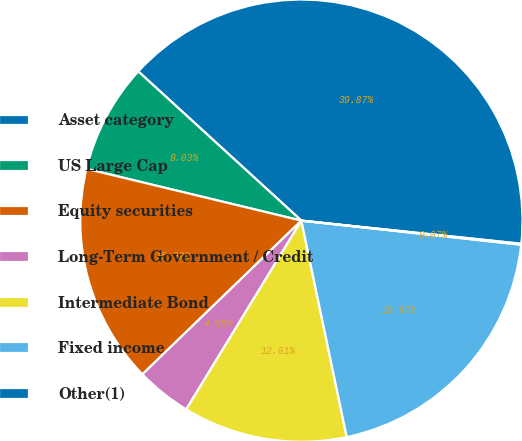Convert chart. <chart><loc_0><loc_0><loc_500><loc_500><pie_chart><fcel>Asset category<fcel>US Large Cap<fcel>Equity securities<fcel>Long-Term Government / Credit<fcel>Intermediate Bond<fcel>Fixed income<fcel>Other(1)<nl><fcel>39.87%<fcel>8.03%<fcel>15.99%<fcel>4.05%<fcel>12.01%<fcel>19.97%<fcel>0.07%<nl></chart> 